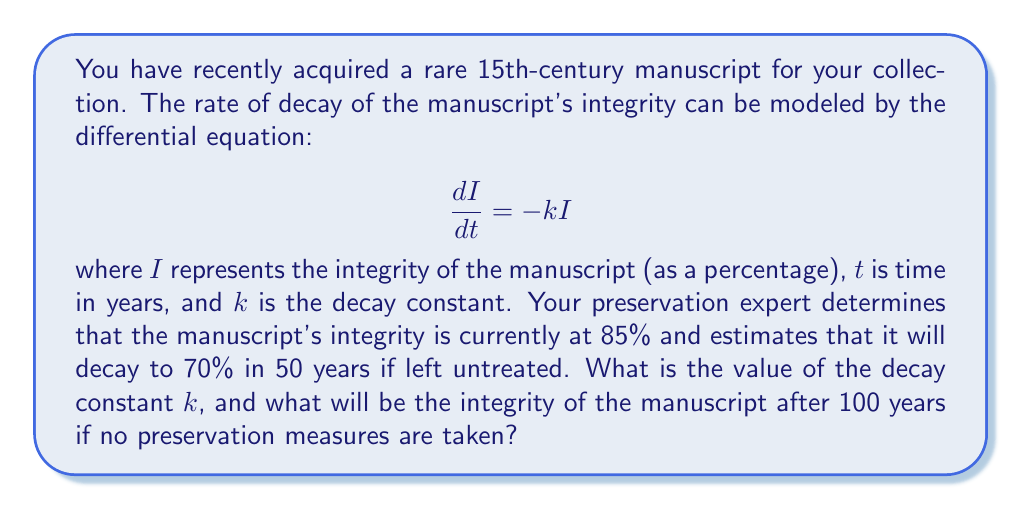Solve this math problem. To solve this problem, we'll follow these steps:

1) The general solution to the differential equation $\frac{dI}{dt} = -kI$ is:

   $$I(t) = I_0e^{-kt}$$

   where $I_0$ is the initial integrity.

2) We're given two points:
   - At $t=0$, $I=85\%$
   - At $t=50$, $I=70\%$

3) Let's use these to find $k$:

   $$70 = 85e^{-50k}$$

4) Dividing both sides by 85:

   $$\frac{70}{85} = e^{-50k}$$

5) Taking the natural log of both sides:

   $$\ln(\frac{70}{85}) = -50k$$

6) Solving for $k$:

   $$k = -\frac{1}{50}\ln(\frac{70}{85}) \approx 0.00388$$

7) Now that we have $k$, we can find the integrity after 100 years:

   $$I(100) = 85e^{-0.00388 \cdot 100} \approx 57.6\%$$
Answer: The decay constant $k$ is approximately 0.00388 per year, and the integrity of the manuscript after 100 years will be approximately 57.6% if no preservation measures are taken. 